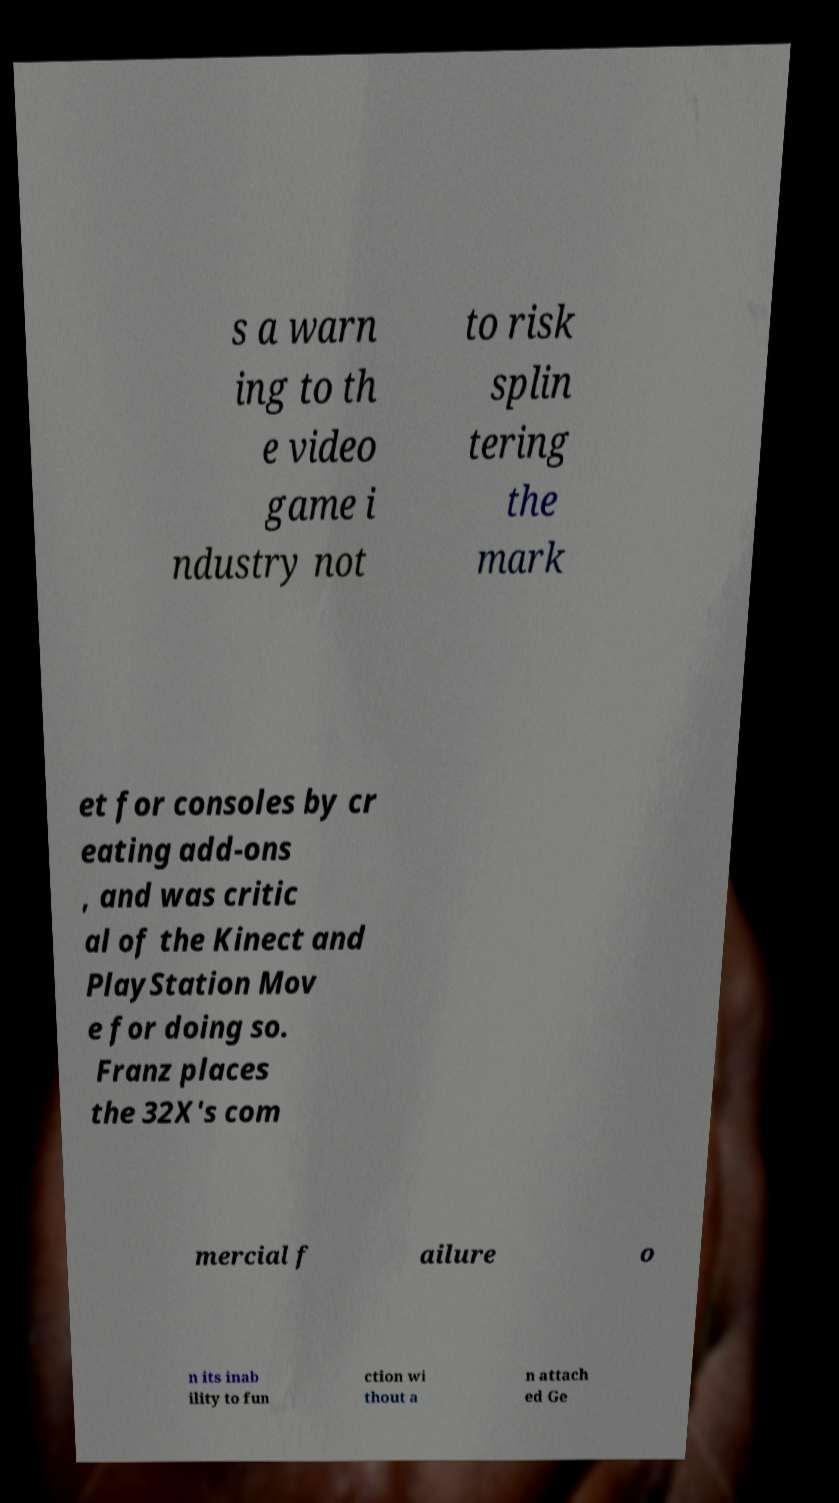Can you read and provide the text displayed in the image?This photo seems to have some interesting text. Can you extract and type it out for me? s a warn ing to th e video game i ndustry not to risk splin tering the mark et for consoles by cr eating add-ons , and was critic al of the Kinect and PlayStation Mov e for doing so. Franz places the 32X's com mercial f ailure o n its inab ility to fun ction wi thout a n attach ed Ge 